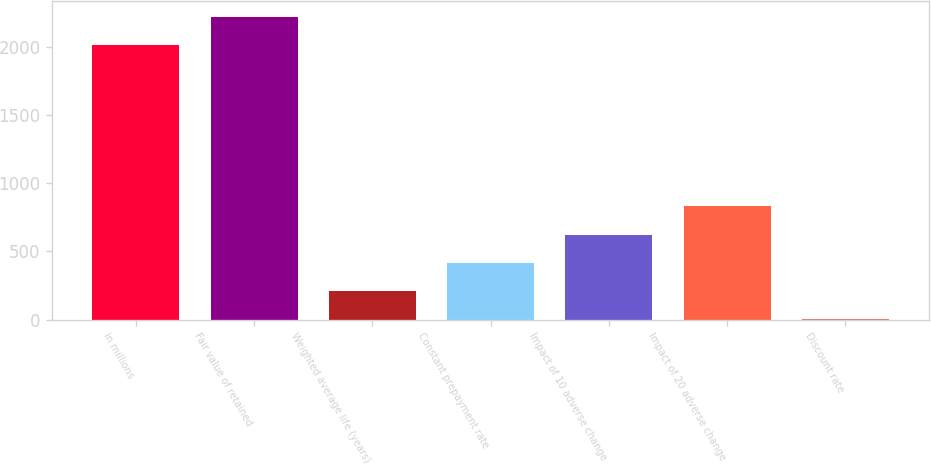Convert chart. <chart><loc_0><loc_0><loc_500><loc_500><bar_chart><fcel>in millions<fcel>Fair value of retained<fcel>Weighted average life (years)<fcel>Constant prepayment rate<fcel>Impact of 10 adverse change<fcel>Impact of 20 adverse change<fcel>Discount rate<nl><fcel>2017<fcel>2223.68<fcel>210.88<fcel>417.56<fcel>624.24<fcel>830.92<fcel>4.2<nl></chart> 